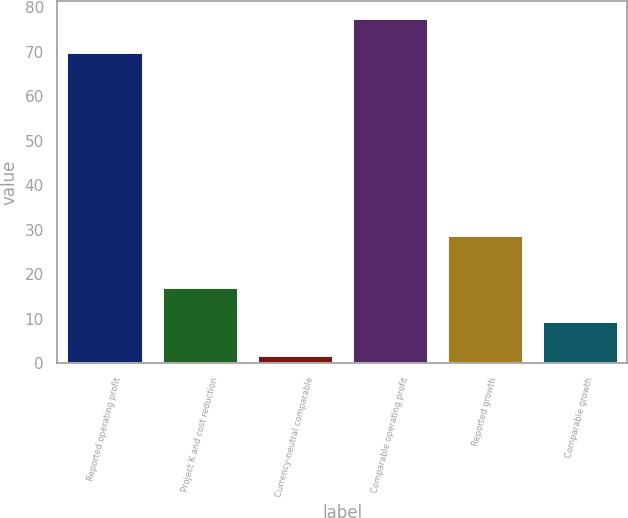<chart> <loc_0><loc_0><loc_500><loc_500><bar_chart><fcel>Reported operating profit<fcel>Project K and cost reduction<fcel>Currency-neutral comparable<fcel>Comparable operating profit<fcel>Reported growth<fcel>Comparable growth<nl><fcel>70<fcel>17.12<fcel>1.9<fcel>77.61<fcel>28.9<fcel>9.51<nl></chart> 